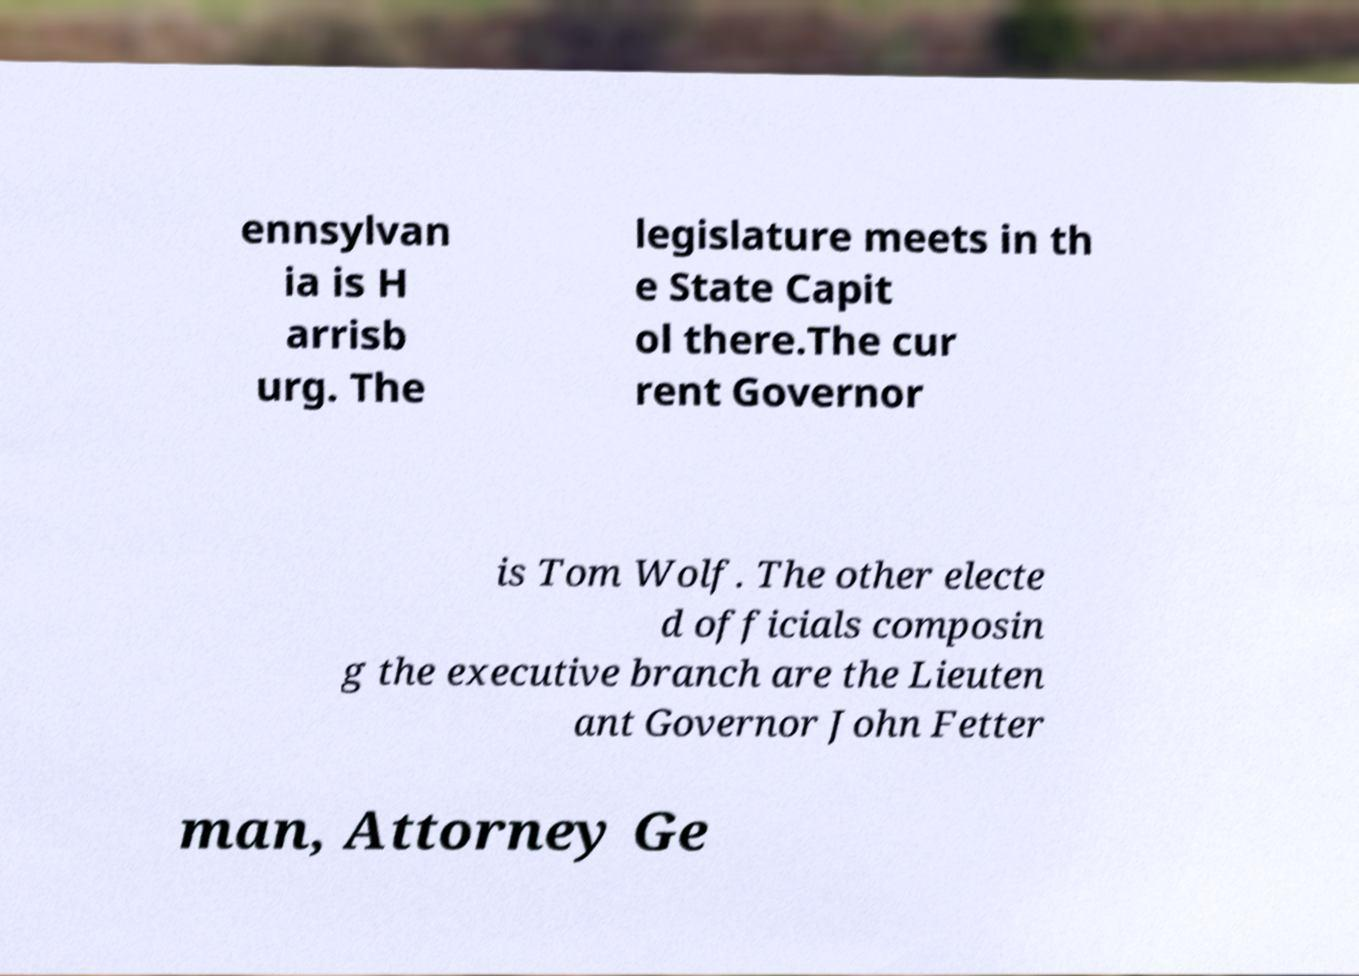For documentation purposes, I need the text within this image transcribed. Could you provide that? ennsylvan ia is H arrisb urg. The legislature meets in th e State Capit ol there.The cur rent Governor is Tom Wolf. The other electe d officials composin g the executive branch are the Lieuten ant Governor John Fetter man, Attorney Ge 